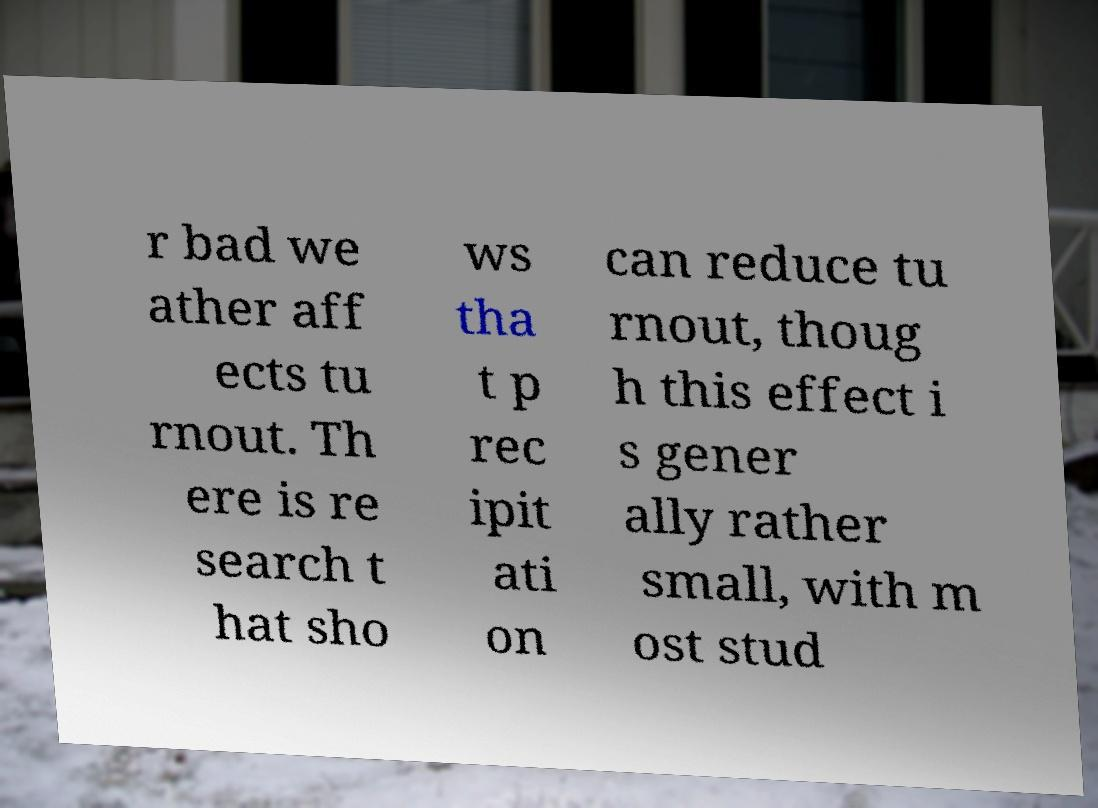For documentation purposes, I need the text within this image transcribed. Could you provide that? r bad we ather aff ects tu rnout. Th ere is re search t hat sho ws tha t p rec ipit ati on can reduce tu rnout, thoug h this effect i s gener ally rather small, with m ost stud 